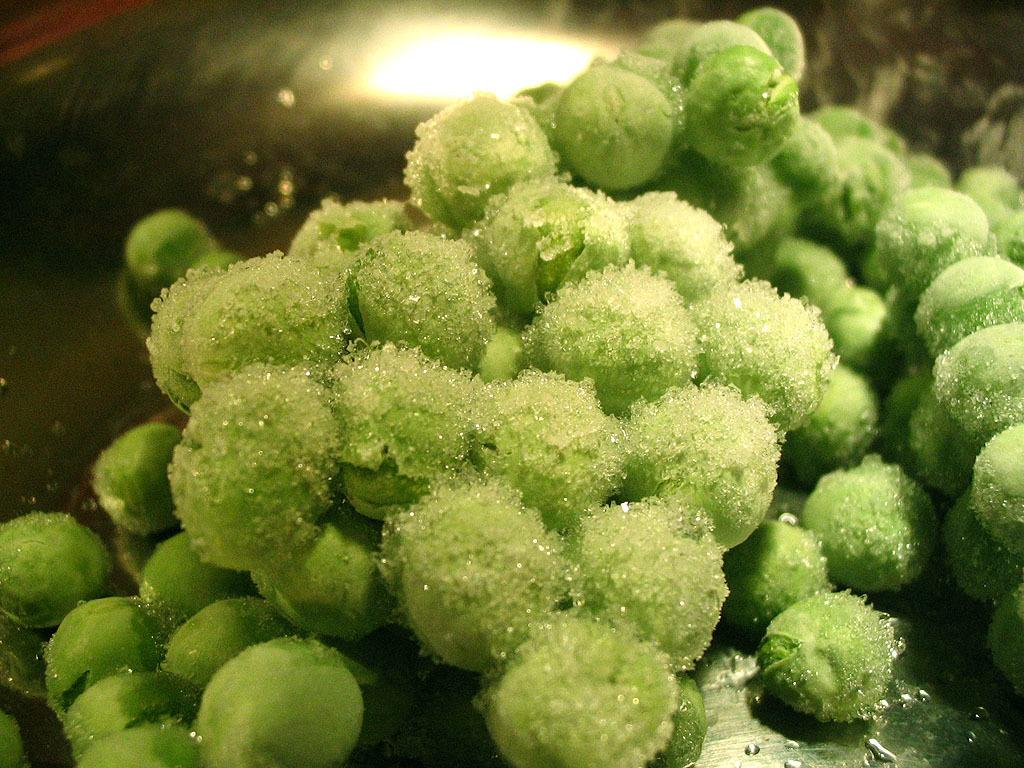What can be seen in the image that is related to food? There is a food item in the image. Can you describe the lighting conditions in the image? There is a light in the background of the image. What type of mint can be seen growing near the food item in the image? There is no mint present in the image, and the food item is not associated with any mint plants. 